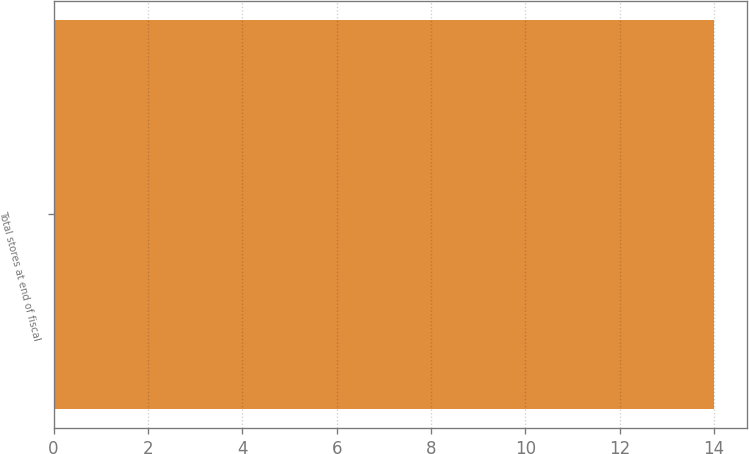<chart> <loc_0><loc_0><loc_500><loc_500><bar_chart><fcel>Total stores at end of fiscal<nl><fcel>14<nl></chart> 